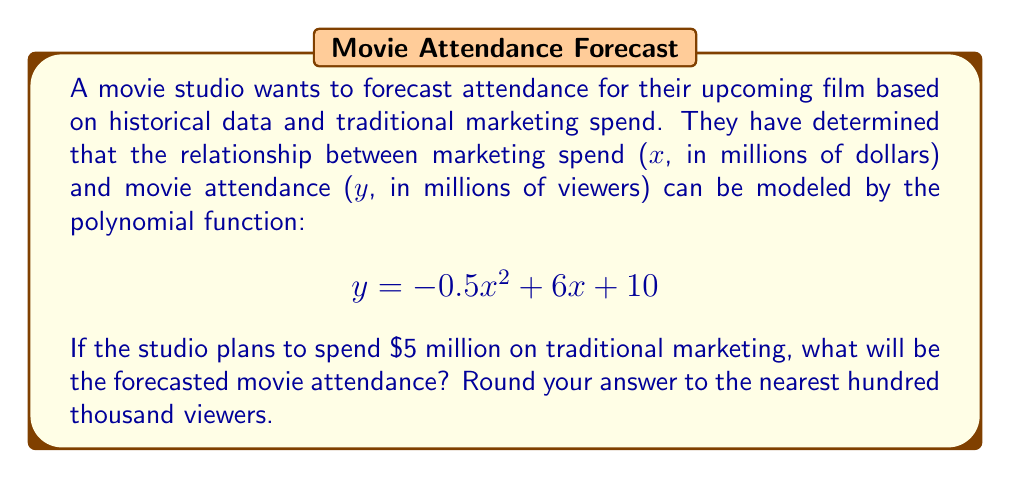What is the answer to this math problem? To solve this problem, we need to substitute the given marketing spend value into the polynomial function and calculate the result. Here's a step-by-step approach:

1. We are given the polynomial function:
   $$ y = -0.5x^2 + 6x + 10 $$

2. The studio plans to spend $5 million on marketing, so we substitute x = 5:
   $$ y = -0.5(5)^2 + 6(5) + 10 $$

3. Let's calculate each term:
   - $-0.5(5)^2 = -0.5(25) = -12.5$
   - $6(5) = 30$
   - The constant term is 10

4. Now, we add these terms:
   $$ y = -12.5 + 30 + 10 = 27.5 $$

5. The result 27.5 represents 27.5 million viewers.

6. Rounding to the nearest hundred thousand:
   27.5 million rounds to 27.5 million (since we're rounding to hundred thousands, the decimal doesn't change)

Therefore, the forecasted movie attendance is 27.5 million viewers.
Answer: 27.5 million viewers 